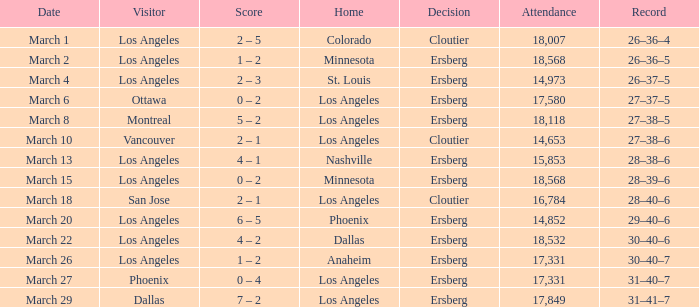What is the Decision listed when the Home was Colorado? Cloutier. 